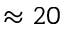Convert formula to latex. <formula><loc_0><loc_0><loc_500><loc_500>\approx 2 0</formula> 